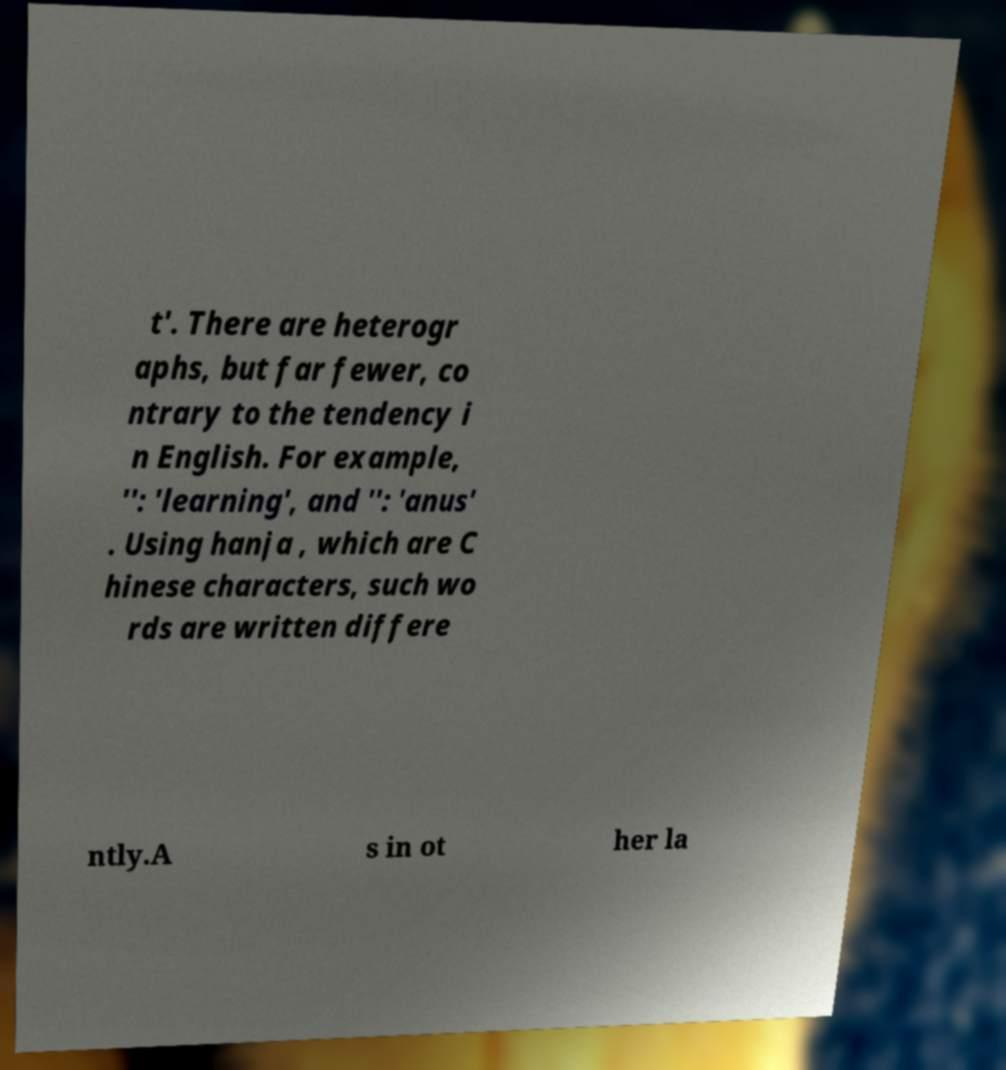Please read and relay the text visible in this image. What does it say? t'. There are heterogr aphs, but far fewer, co ntrary to the tendency i n English. For example, '': 'learning', and '': 'anus' . Using hanja , which are C hinese characters, such wo rds are written differe ntly.A s in ot her la 